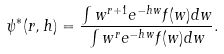<formula> <loc_0><loc_0><loc_500><loc_500>\psi ^ { * } ( r , h ) = \frac { \int w ^ { r + 1 } e ^ { - h w } f ( w ) d w } { \int w ^ { r } e ^ { - h w } f ( w ) d w } .</formula> 